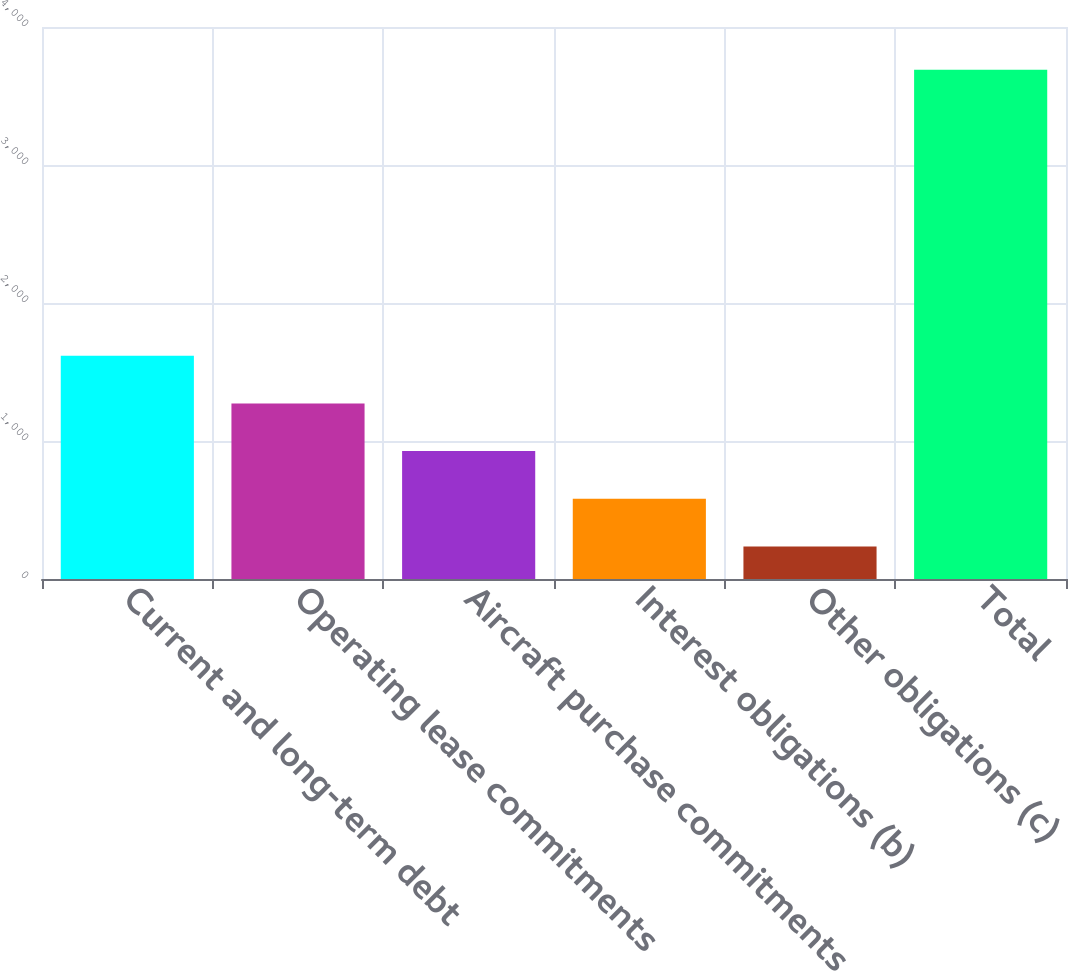Convert chart to OTSL. <chart><loc_0><loc_0><loc_500><loc_500><bar_chart><fcel>Current and long-term debt<fcel>Operating lease commitments<fcel>Aircraft purchase commitments<fcel>Interest obligations (b)<fcel>Other obligations (c)<fcel>Total<nl><fcel>1617.96<fcel>1272.47<fcel>926.98<fcel>581.49<fcel>236<fcel>3690.9<nl></chart> 